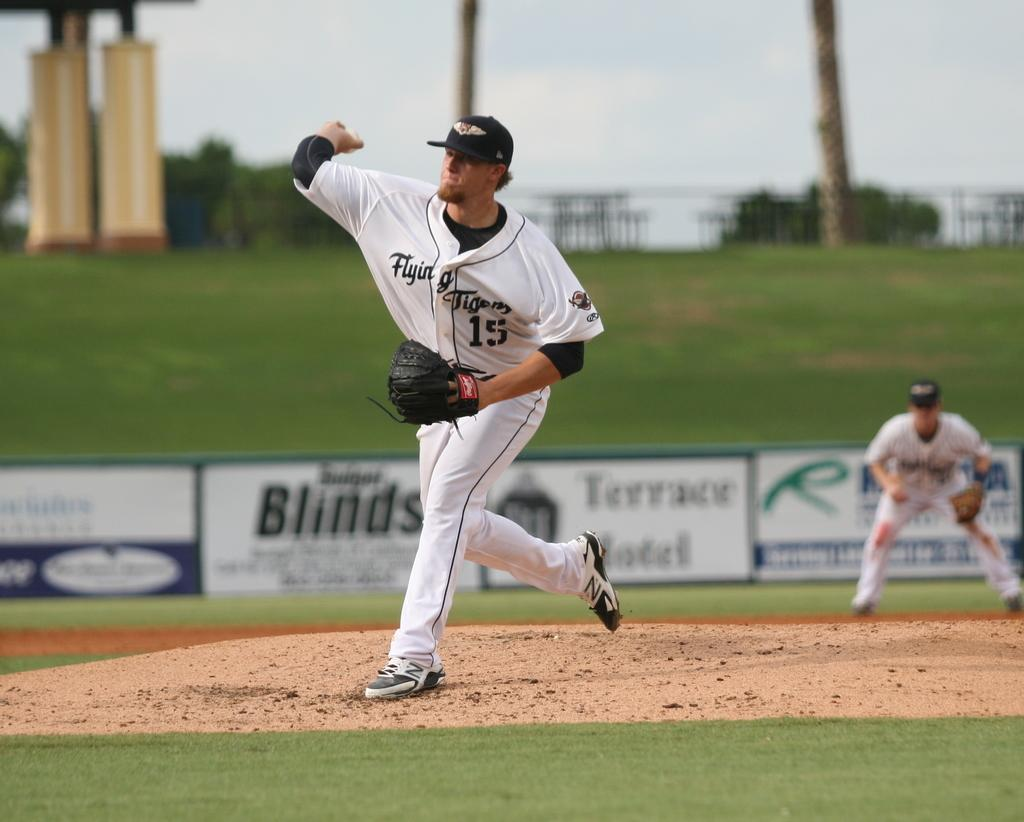<image>
Present a compact description of the photo's key features. Number 15 is pitching a ball at the baseball field. 